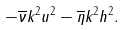Convert formula to latex. <formula><loc_0><loc_0><loc_500><loc_500>\, - \overline { \nu } { k ^ { 2 } u ^ { 2 } } - \overline { \eta } { k ^ { 2 } h ^ { 2 } } .</formula> 